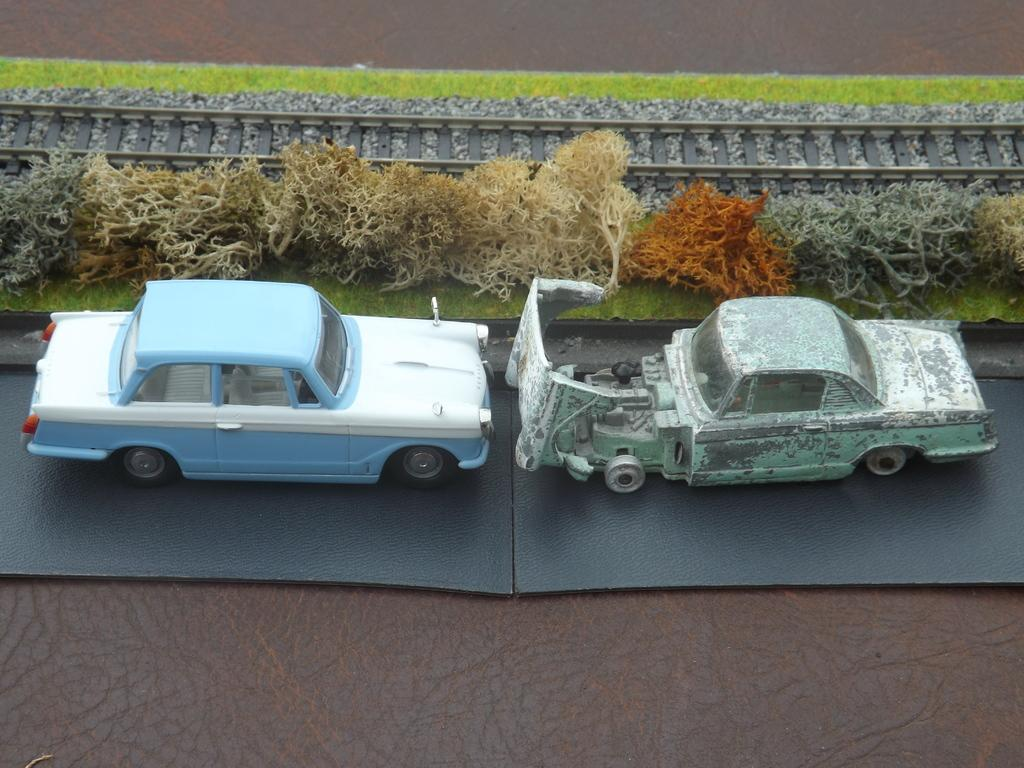How many cars are visible in the image? There are two cars in the image. What else can be seen in the image besides the cars? There are plants and a railway track in the image. What type of produce is being harvested near the railway track in the image? There is no produce or harvesting activity visible in the image; it only shows two cars, plants, and a railway track. 